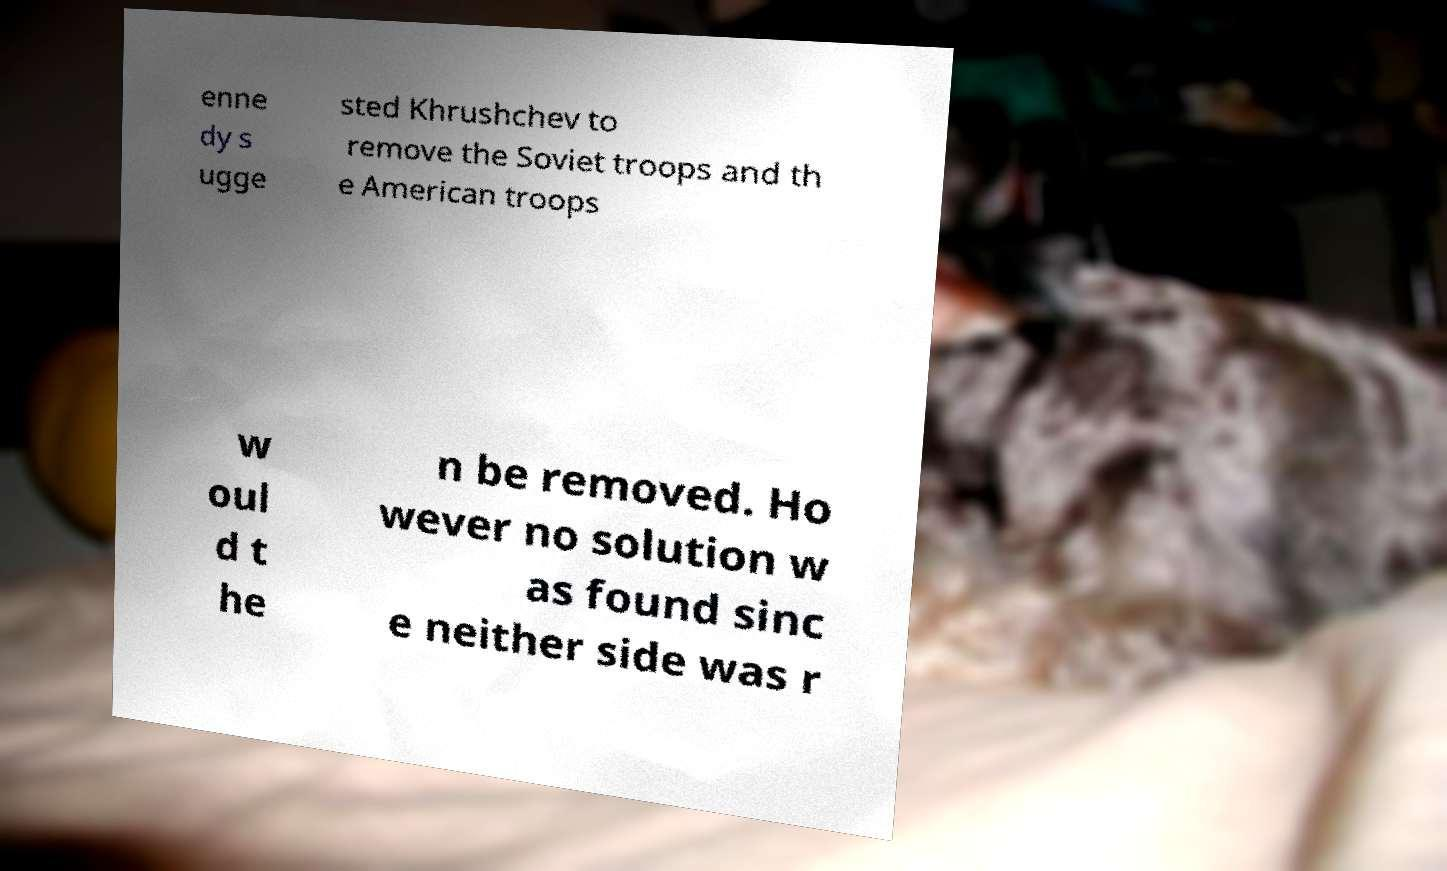I need the written content from this picture converted into text. Can you do that? enne dy s ugge sted Khrushchev to remove the Soviet troops and th e American troops w oul d t he n be removed. Ho wever no solution w as found sinc e neither side was r 